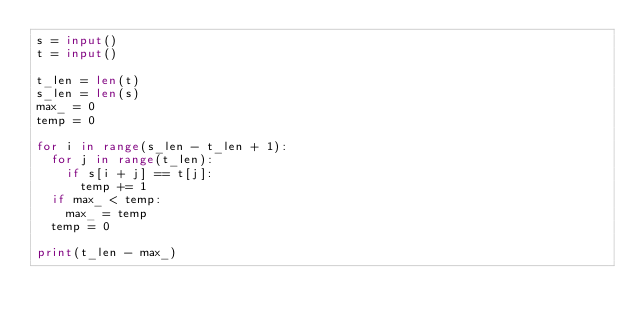Convert code to text. <code><loc_0><loc_0><loc_500><loc_500><_Python_>s = input()
t = input()

t_len = len(t)
s_len = len(s)
max_ = 0
temp = 0

for i in range(s_len - t_len + 1):
  for j in range(t_len):
    if s[i + j] == t[j]:
      temp += 1
  if max_ < temp:
    max_ = temp
  temp = 0

print(t_len - max_)</code> 